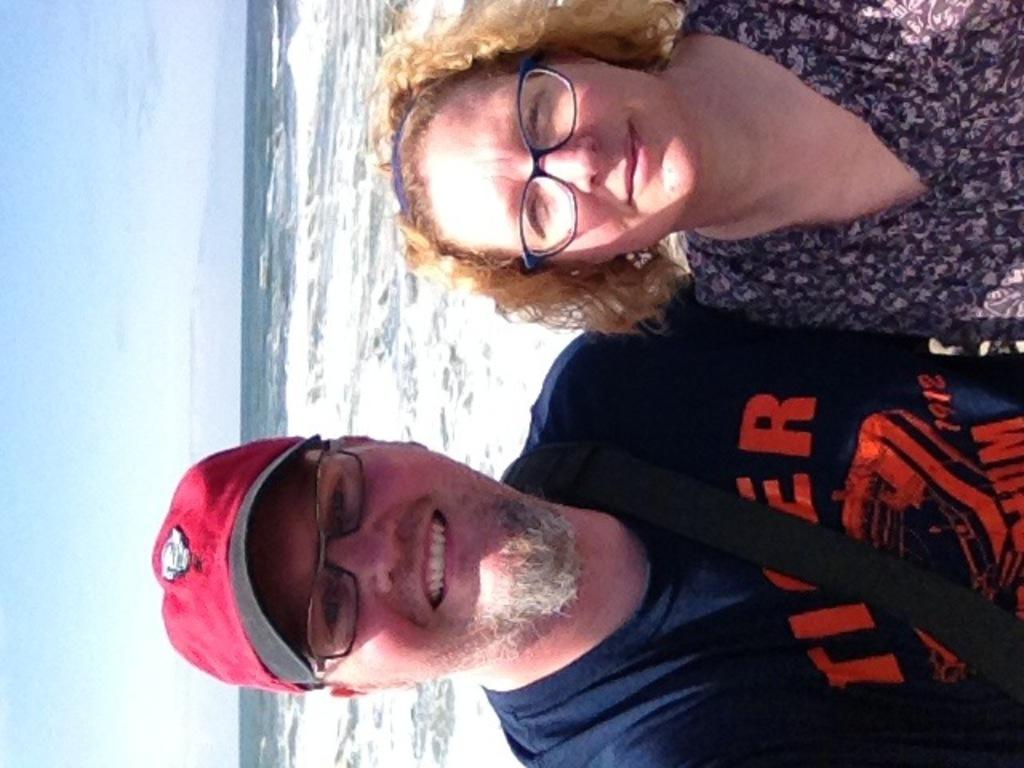What is the gender of the person in the image wearing spectacles and smiling? There are two people in the image wearing spectacles and smiling, a man and a woman. What is the facial expression of the man in the image? The man in the image is smiling. What is the facial expression of the woman in the image? The woman in the image is also smiling. What can be seen in the background of the image? Water and sky are visible in the background of the image. Can you tell me how many snakes are slithering in the water in the image? There are no snakes visible in the image; only water and sky can be seen in the background. What type of boats are present in the image? There are no boats present in the image; only water and sky can be seen in the background. 